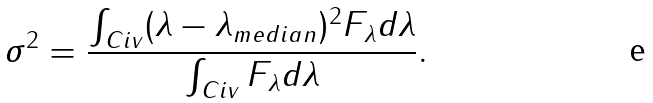Convert formula to latex. <formula><loc_0><loc_0><loc_500><loc_500>\sigma ^ { 2 } = \frac { \int _ { C i v } ( \lambda - \lambda _ { m e d i a n } ) ^ { 2 } F _ { \lambda } d \lambda } { \int _ { C i v } F _ { \lambda } d \lambda } .</formula> 